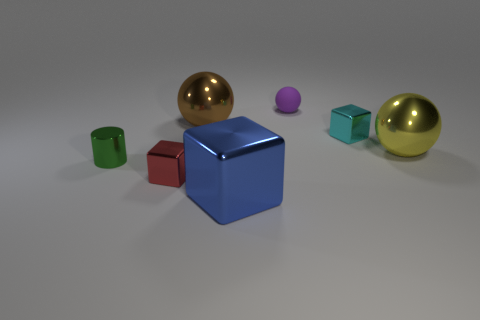Are there any other things that are the same material as the tiny ball?
Ensure brevity in your answer.  No. Are there fewer yellow spheres than tiny yellow shiny cylinders?
Provide a short and direct response. No. What is the material of the small purple thing behind the large metallic thing that is on the right side of the cyan metal thing?
Make the answer very short. Rubber. Is the purple rubber sphere the same size as the brown sphere?
Provide a succinct answer. No. What number of objects are small brown things or small blocks?
Provide a short and direct response. 2. There is a metal cube that is both in front of the metallic cylinder and on the right side of the big brown metallic object; what is its size?
Ensure brevity in your answer.  Large. Are there fewer big cubes to the right of the big brown object than big balls?
Provide a short and direct response. Yes. The cyan object that is the same material as the blue thing is what shape?
Your answer should be very brief. Cube. There is a big shiny thing that is to the right of the tiny rubber thing; does it have the same shape as the big metallic object to the left of the large blue shiny block?
Give a very brief answer. Yes. Is the number of small rubber balls in front of the tiny purple object less than the number of tiny cubes that are behind the tiny red metallic object?
Provide a short and direct response. Yes. 